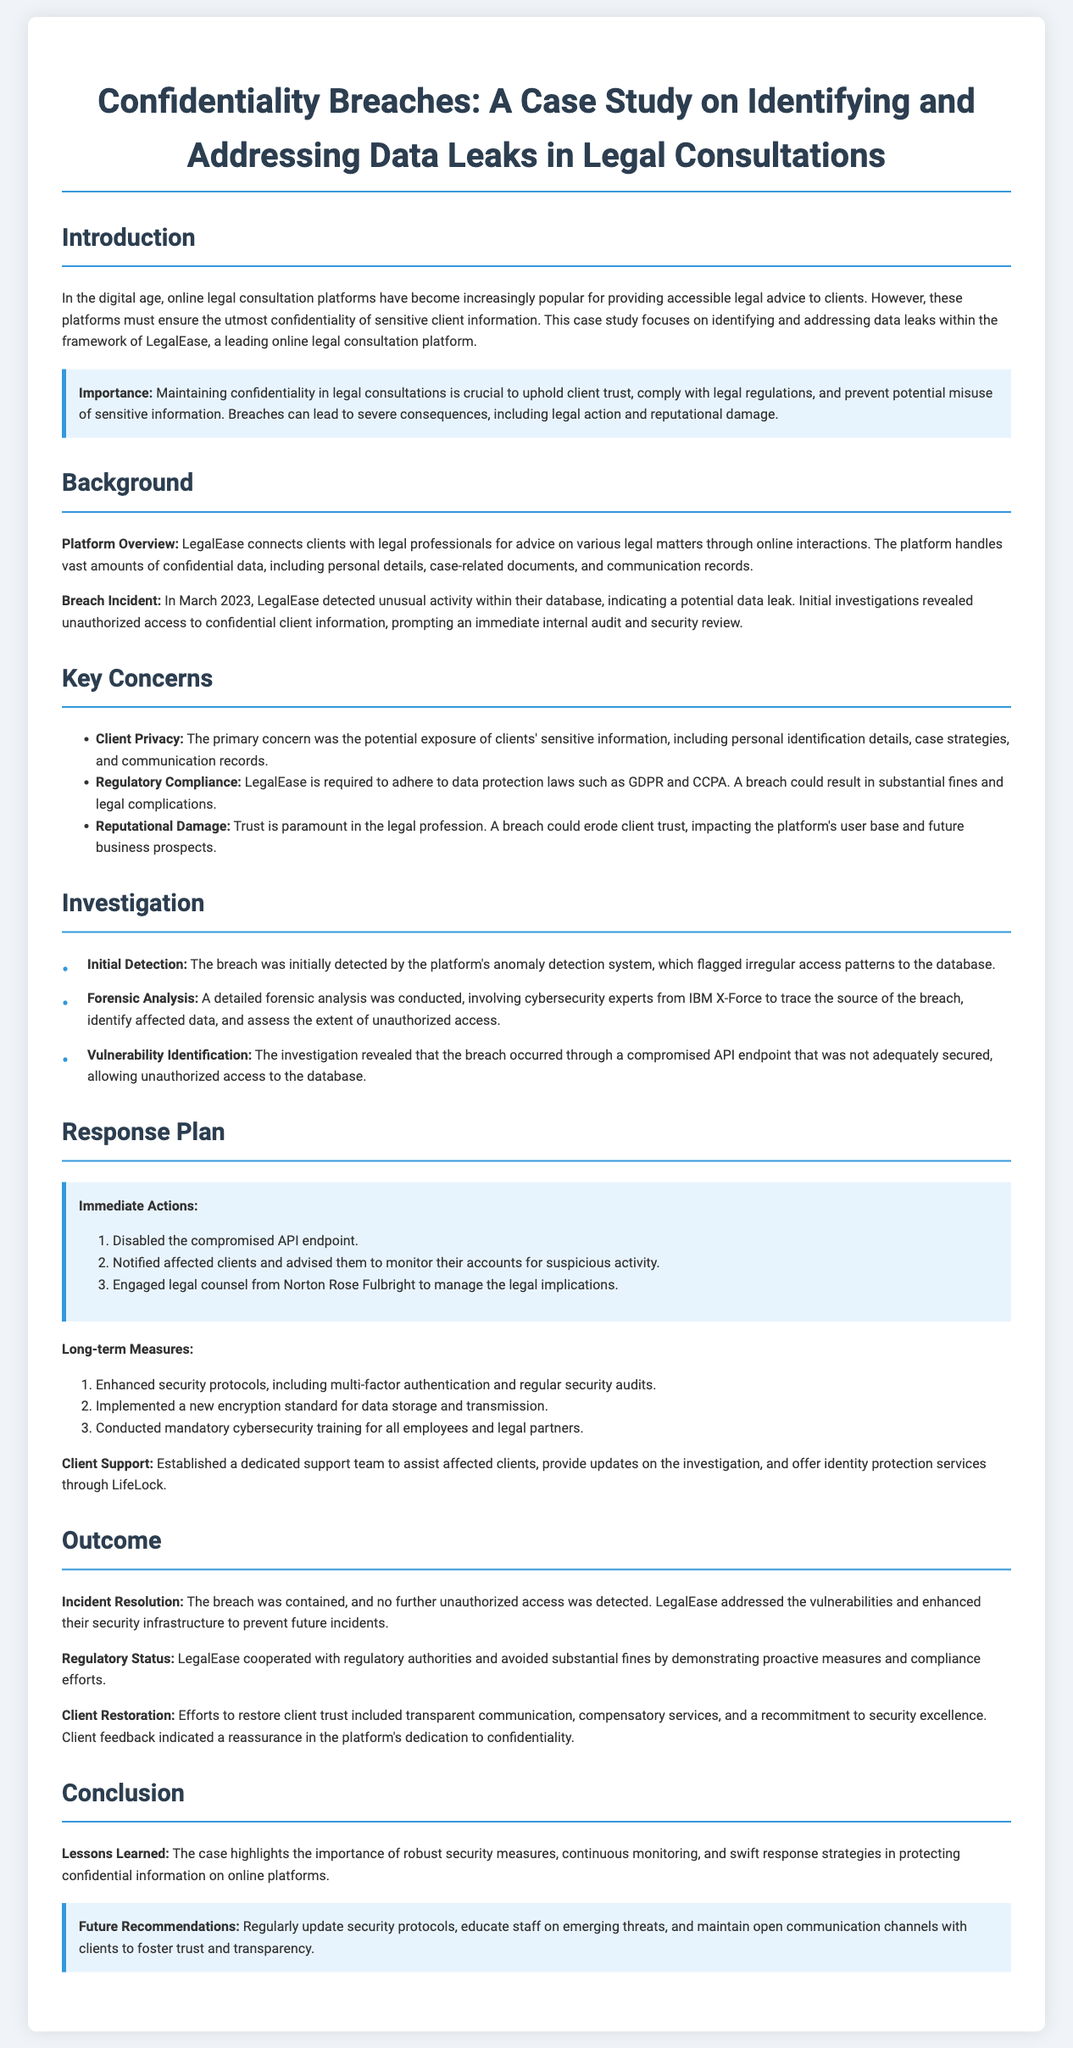What was the platform's name? The document refers to the online legal consultation platform as LegalEase.
Answer: LegalEase When was the breach incident detected? The breach incident was detected in March 2023, as mentioned in the document.
Answer: March 2023 What type of system initially detected the breach? The breach was initially detected by the platform's anomaly detection system, according to the investigation section.
Answer: anomaly detection system Who was engaged to manage the legal implications? The document states that legal counsel from Norton Rose Fulbright was engaged for this purpose.
Answer: Norton Rose Fulbright What immediate action was taken first in response to the breach? The first immediate action taken was disabling the compromised API endpoint, as listed in the response plan.
Answer: Disabled the compromised API endpoint What was identified as the cause of the breach? The investigation revealed that the breach occurred through a compromised API endpoint that was not adequately secured.
Answer: compromised API endpoint What long-term measure was implemented for data storage? The document specifies that a new encryption standard for data storage and transmission was implemented as a long-term measure.
Answer: new encryption standard How did LegalEase cooperate with regulatory authorities? LegalEase cooperated with regulatory authorities to avoid substantial fines, demonstrating proactive measures and compliance efforts.
Answer: cooperative measures What aspect is crucial to maintain client trust, according to the introduction? The document emphasizes that maintaining confidentiality in legal consultations is crucial to uphold client trust.
Answer: maintaining confidentiality 